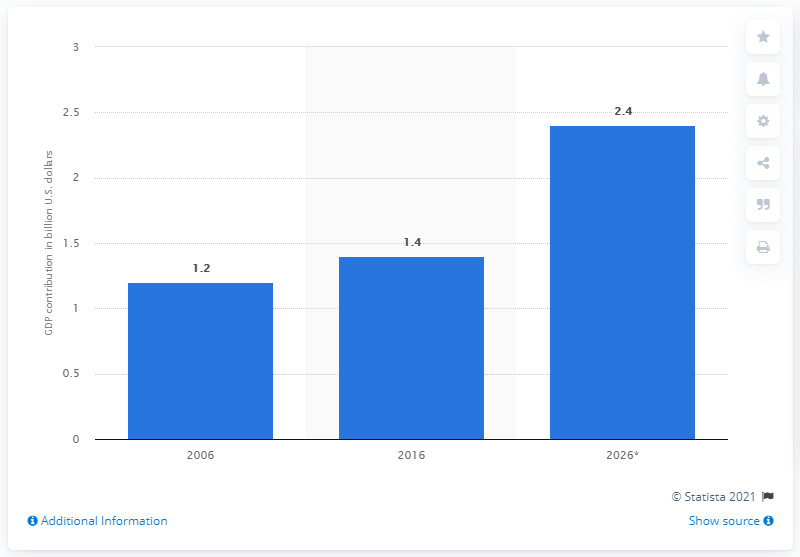Draw attention to some important aspects in this diagram. The direct tourism contribution of Cairo to the GDP of Egypt in 2026 was 2.4%. 